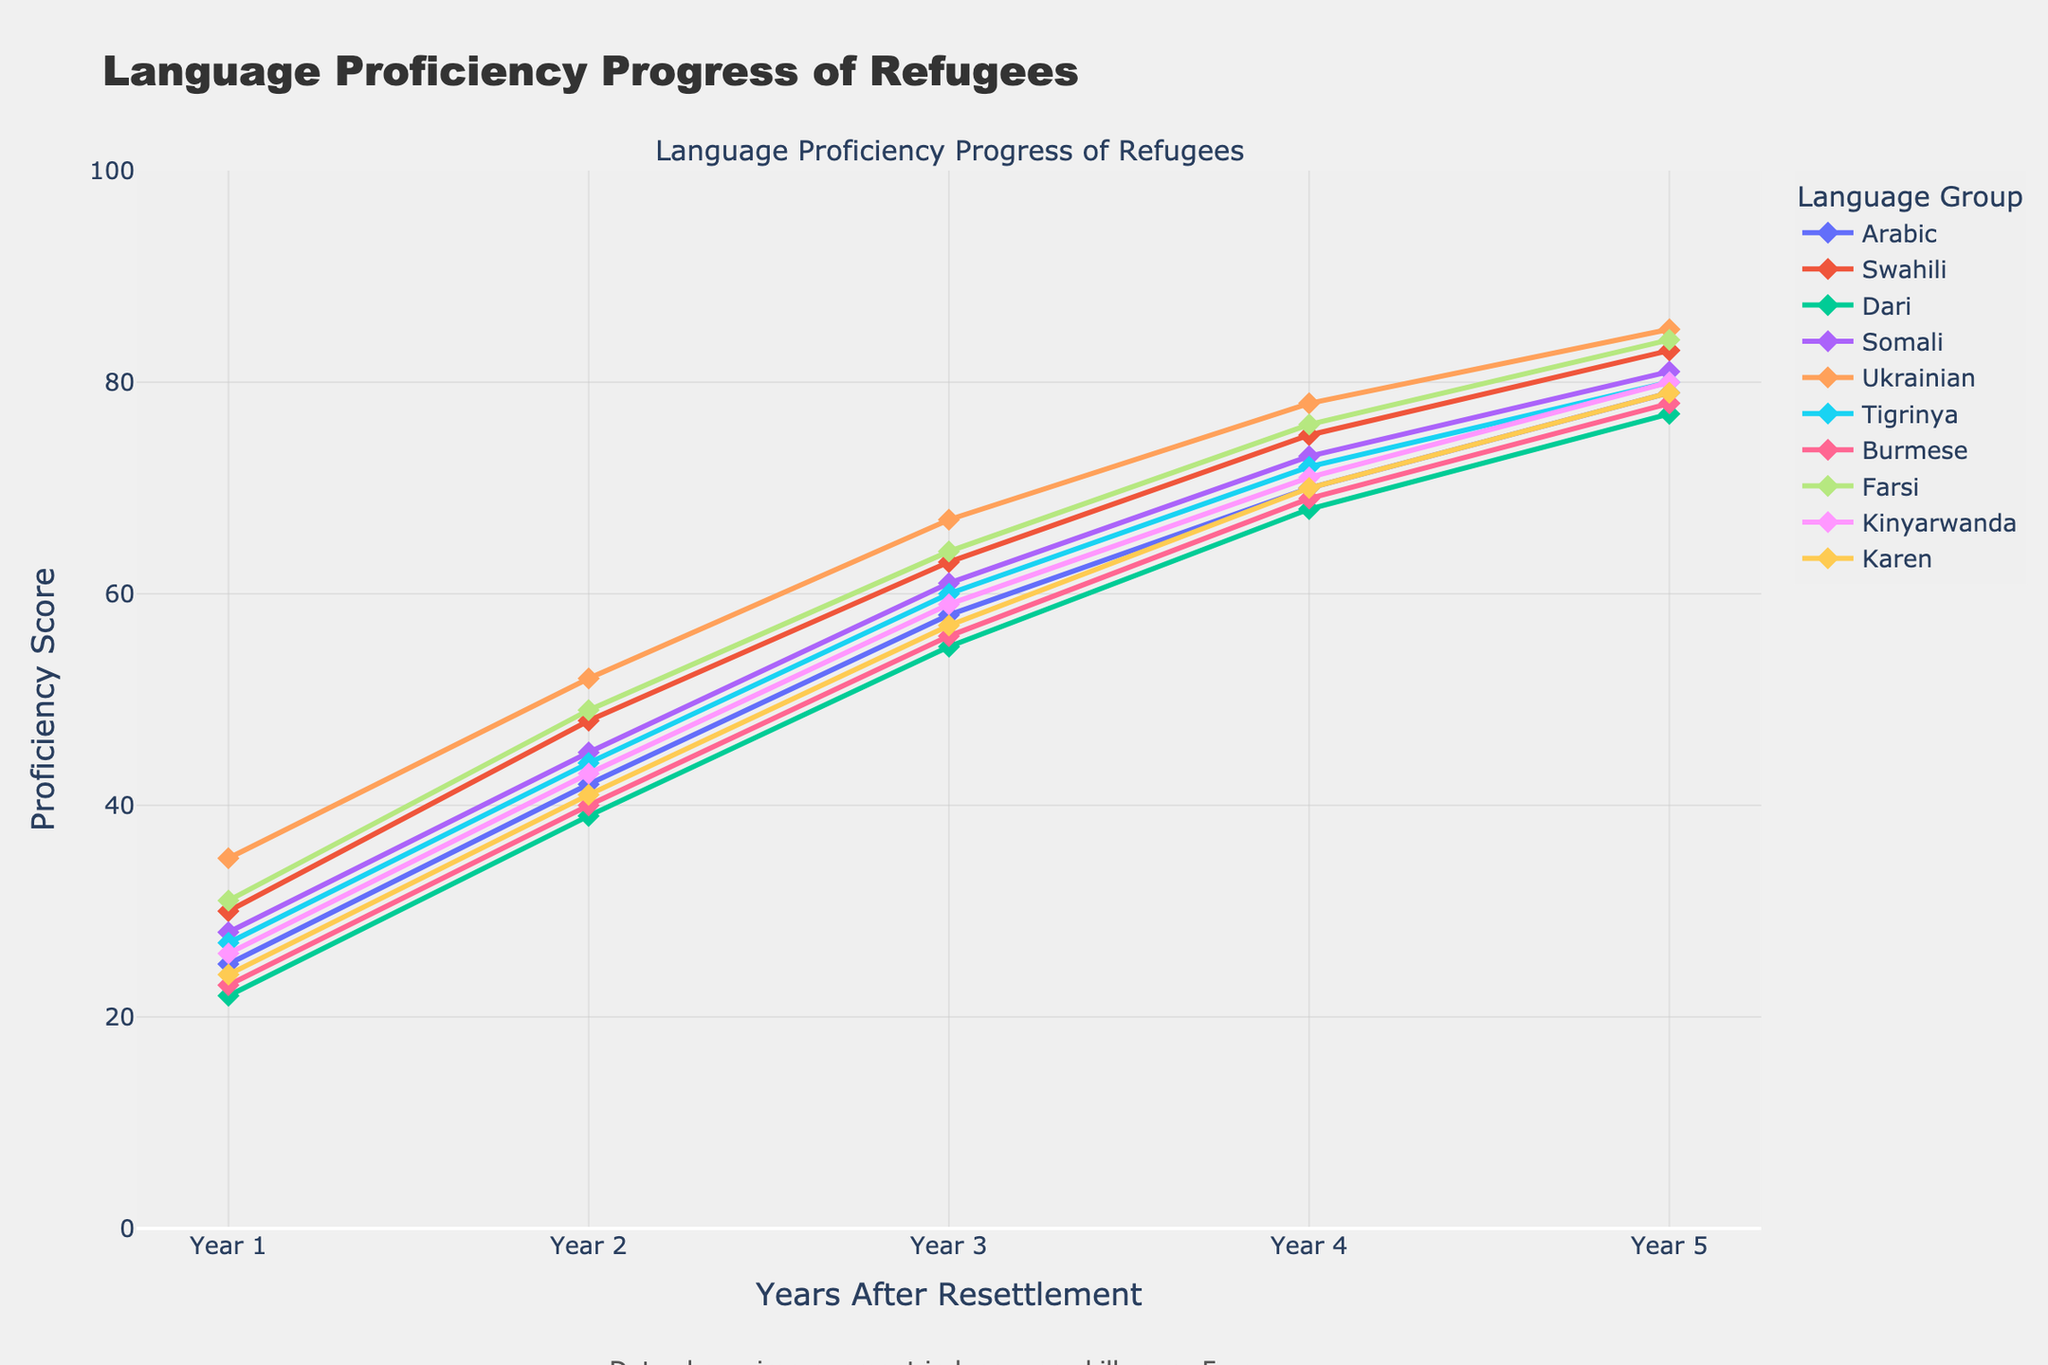What is the overall trend for language proficiency over the 5-year period? The plot shows all language groups starting at lower proficiency scores in Year 1 and steadily increasing each year until Year 5, indicating an overall trend of improvement in language proficiency.
Answer: Improvement Which language group has the highest proficiency score in Year 5? By examining the ending points of the lines in Year 5, the Ukrainian group has the highest proficiency score at 85.
Answer: Ukrainian How much did the Arabic group improve from Year 1 to Year 5? The Arabic group started at a proficiency score of 25 in Year 1 and increased to 79 in Year 5. The improvement is calculated as 79 - 25 = 54.
Answer: 54 Which language groups have similar proficiency scores in Year 3? By looking at the values for Year 3, Arabic (58), Tigrinya (60), Somali (61), and Karen (57) have similar proficiency scores. These values are visually close in the plot.
Answer: Arabic, Tigrinya, Somali, Karen What is the average proficiency score across all language groups in Year 2? The values in Year 2 are 42, 48, 39, 45, 52, 44, 40, 49, 43, and 41. The sum is 443, and the average is 443 / 10 = 44.3.
Answer: 44.3 Which two language groups show the most significant proficiency improvement between Year 2 and Year 4? By checking the differences between Year 2 and Year 4, Ukrainian (78 - 52 = 26) and Farsi (76 - 49 = 27) both show large improvements.
Answer: Ukrainian, Farsi Did any language group show a plateau or decline at any point within the 5 years? All language groups show an upward trend with no plateaus or declines; lines are ascending consistently without flat sections.
Answer: No How does the proficiency growth of Swahili compare to Burmese over the 5 years? Swahili starts at 30 and ends at 83, for an improvement of 53 points. Burmese starts at 23 and ends at 78, for an improvement of 55 points. Swahili’s growth is slightly less than Burmese by 2 points, although the trends are visually similar.
Answer: Slightly less What is the median proficiency score for the Farsi group over the 5 years? The Farsi group's proficiency scores are 31, 49, 64, 76, and 84. Arranging them: 31, 49, 64, 76, 84; the median is the middle value, 64.
Answer: 64 